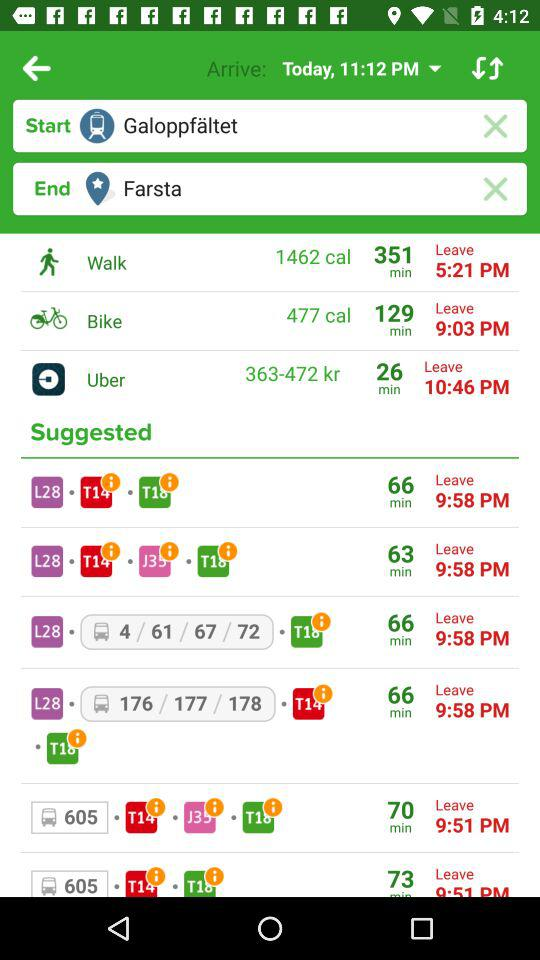What is the starting location? The starting location is "Galoppfaltet". 